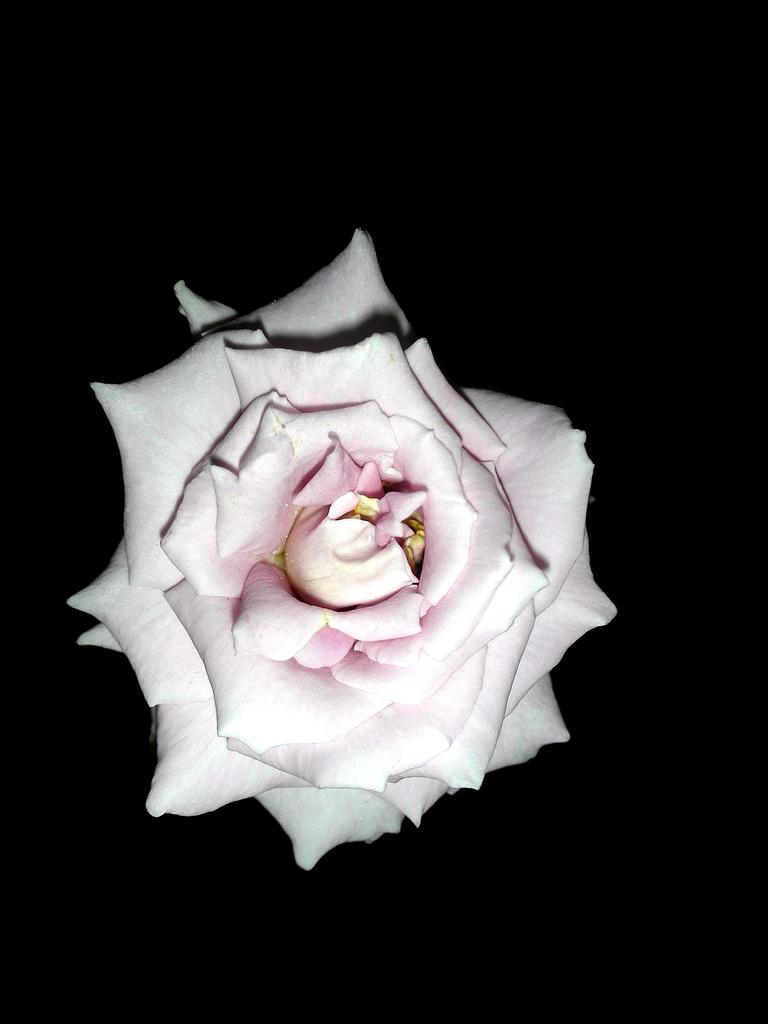What type of flower is in the image? There is a rose flower in the image. How would you describe the background of the image? The background of the rose flower is dark. What type of fork can be seen in the image? There is no fork present in the image; it only features a rose flower with a dark background. What discovery was made while examining the image? There is no discovery mentioned or implied in the image, as it only features a rose flower with a dark background. 